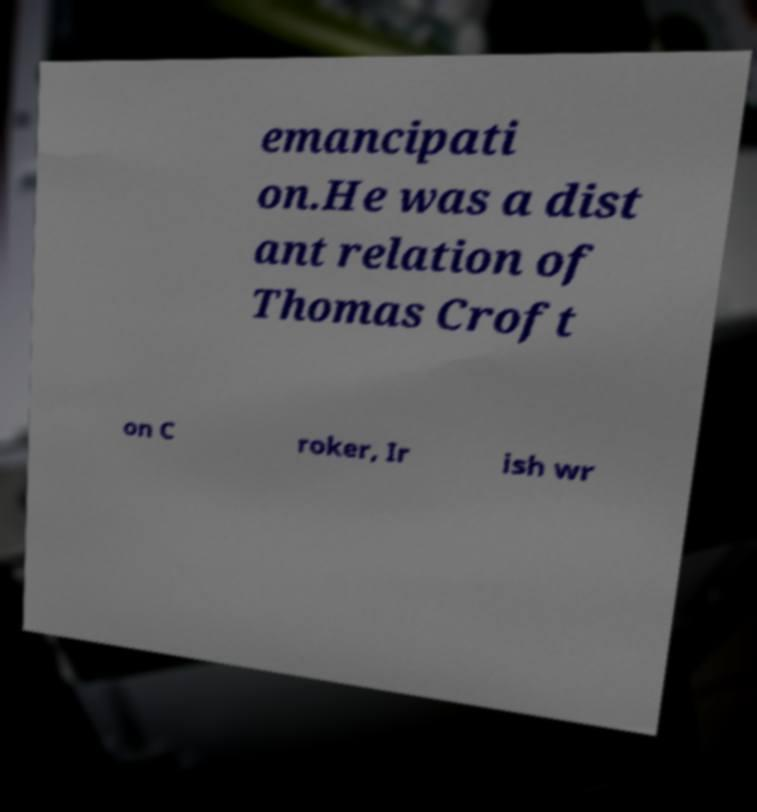There's text embedded in this image that I need extracted. Can you transcribe it verbatim? emancipati on.He was a dist ant relation of Thomas Croft on C roker, Ir ish wr 